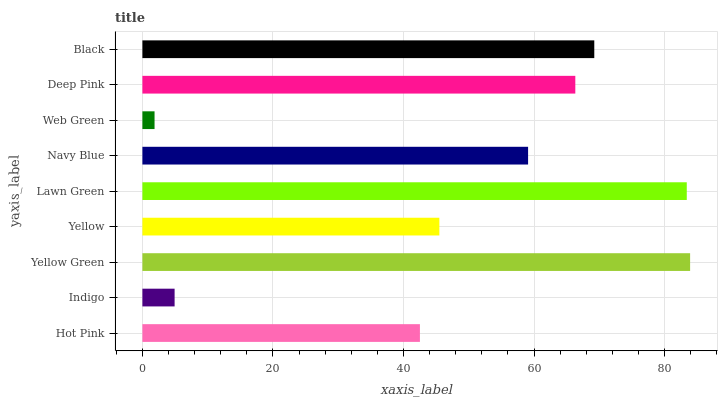Is Web Green the minimum?
Answer yes or no. Yes. Is Yellow Green the maximum?
Answer yes or no. Yes. Is Indigo the minimum?
Answer yes or no. No. Is Indigo the maximum?
Answer yes or no. No. Is Hot Pink greater than Indigo?
Answer yes or no. Yes. Is Indigo less than Hot Pink?
Answer yes or no. Yes. Is Indigo greater than Hot Pink?
Answer yes or no. No. Is Hot Pink less than Indigo?
Answer yes or no. No. Is Navy Blue the high median?
Answer yes or no. Yes. Is Navy Blue the low median?
Answer yes or no. Yes. Is Lawn Green the high median?
Answer yes or no. No. Is Hot Pink the low median?
Answer yes or no. No. 